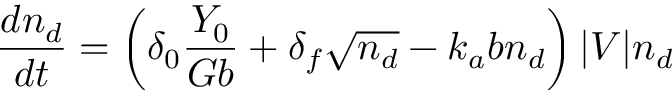<formula> <loc_0><loc_0><loc_500><loc_500>\frac { d n _ { d } } { d t } = \left ( \delta _ { 0 } \frac { Y _ { 0 } } { G b } + \delta _ { f } \sqrt { n _ { d } } - k _ { a } b n _ { d } \right ) | V | n _ { d }</formula> 